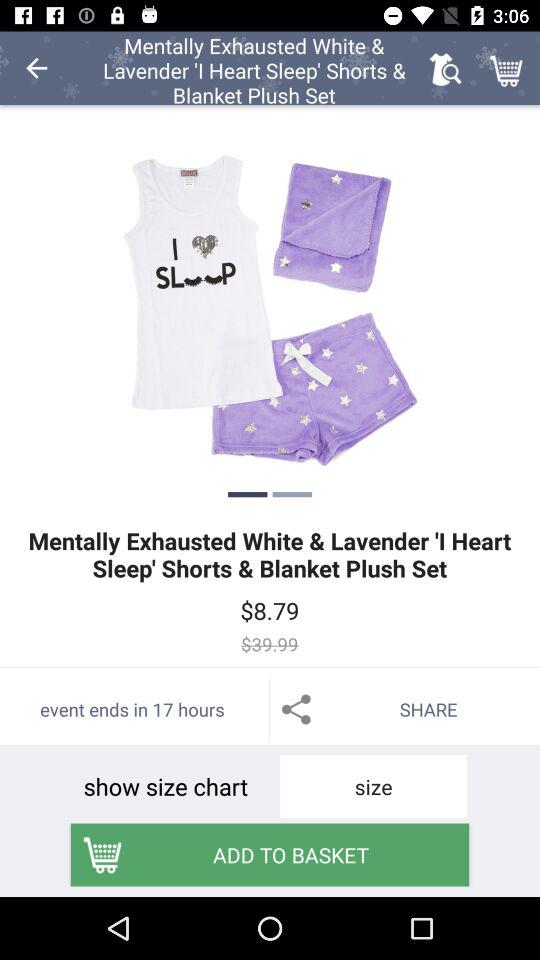How much less is the original price than the sale price?
Answer the question using a single word or phrase. $31.20 